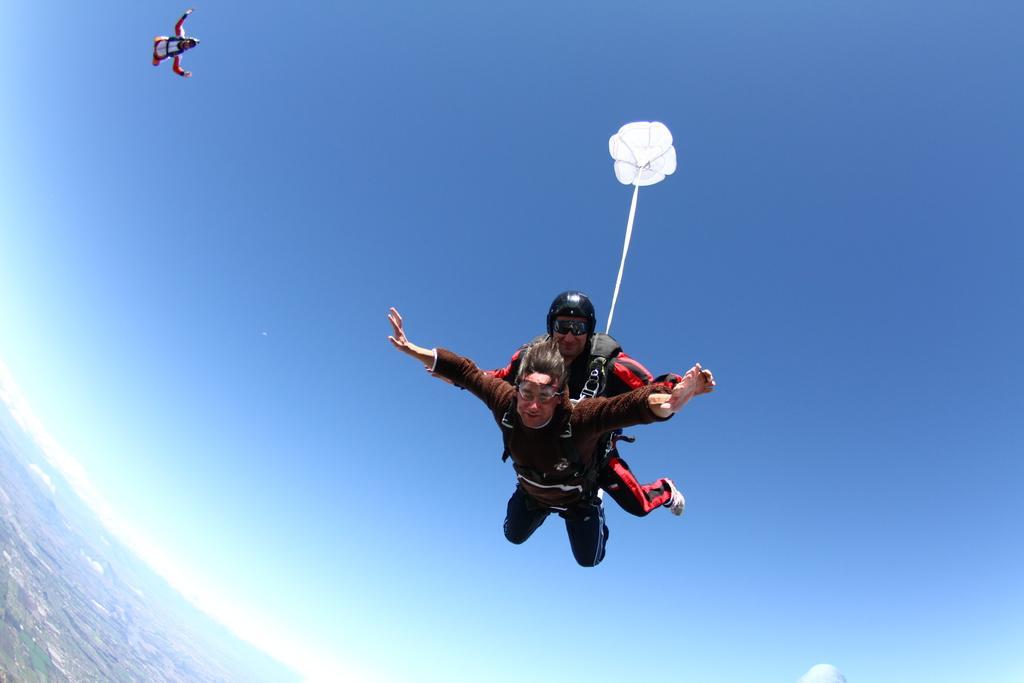Describe this image in one or two sentences. Here we can see three persons are sky diving and on the left at the bottom corner we can see clouds and it is the top view from the sky to the earth. 